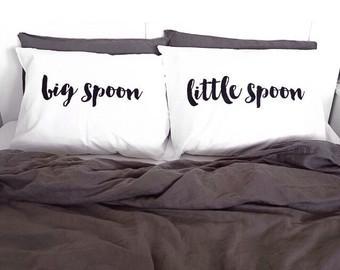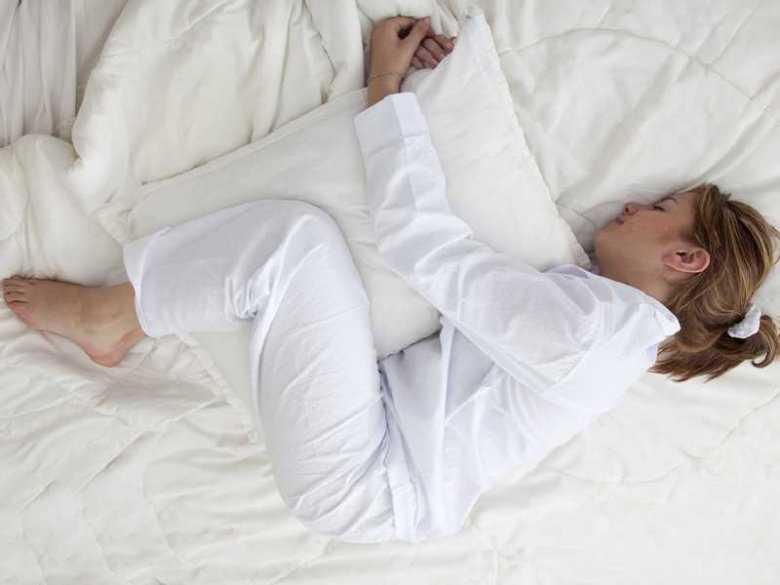The first image is the image on the left, the second image is the image on the right. Evaluate the accuracy of this statement regarding the images: "there are humans sleeping". Is it true? Answer yes or no. Yes. The first image is the image on the left, the second image is the image on the right. Evaluate the accuracy of this statement regarding the images: "There is no less than one sleeping woman visible". Is it true? Answer yes or no. Yes. 